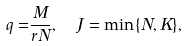<formula> <loc_0><loc_0><loc_500><loc_500>q = & \frac { M } { r N } , \quad J = \min \{ N , K \} ,</formula> 